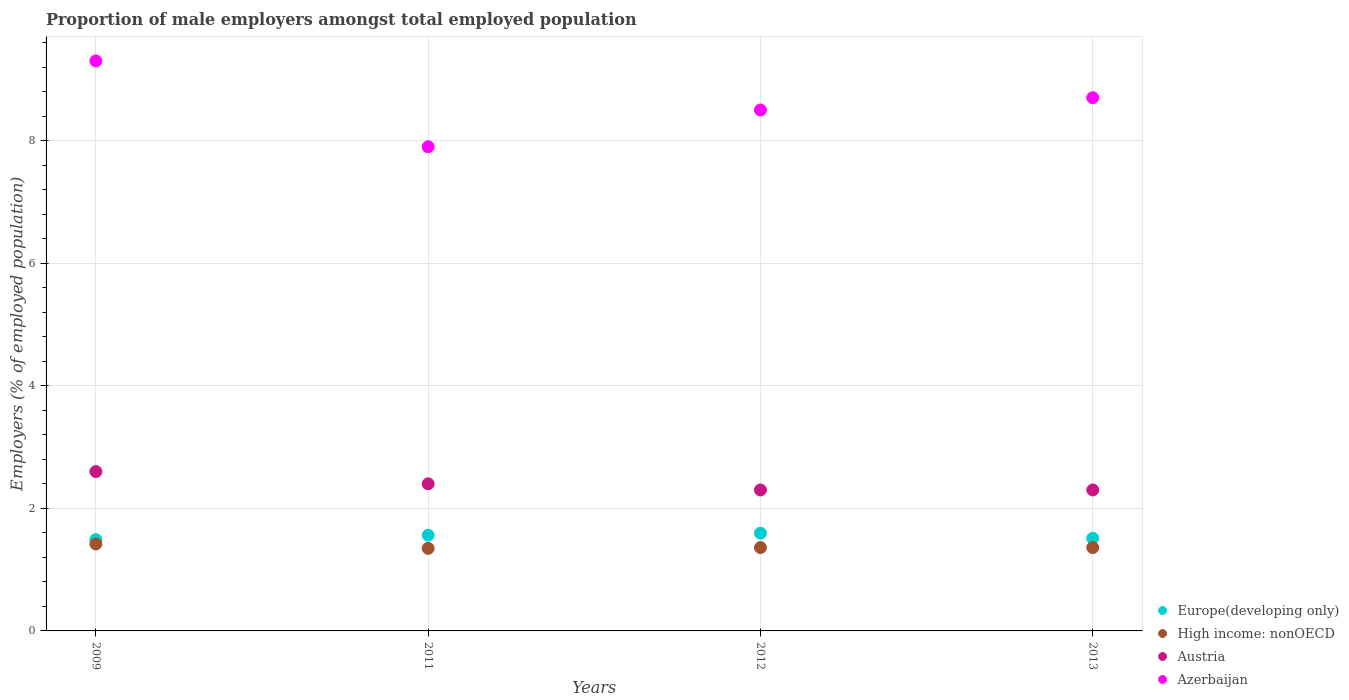What is the proportion of male employers in Austria in 2009?
Give a very brief answer. 2.6. Across all years, what is the maximum proportion of male employers in Azerbaijan?
Your response must be concise. 9.3. Across all years, what is the minimum proportion of male employers in Austria?
Keep it short and to the point. 2.3. In which year was the proportion of male employers in High income: nonOECD minimum?
Your answer should be very brief. 2011. What is the total proportion of male employers in Azerbaijan in the graph?
Offer a very short reply. 34.4. What is the difference between the proportion of male employers in High income: nonOECD in 2011 and that in 2013?
Keep it short and to the point. -0.01. What is the difference between the proportion of male employers in High income: nonOECD in 2013 and the proportion of male employers in Azerbaijan in 2012?
Keep it short and to the point. -7.14. What is the average proportion of male employers in Europe(developing only) per year?
Offer a very short reply. 1.54. In the year 2012, what is the difference between the proportion of male employers in Austria and proportion of male employers in High income: nonOECD?
Keep it short and to the point. 0.94. What is the ratio of the proportion of male employers in Europe(developing only) in 2011 to that in 2013?
Your answer should be compact. 1.03. What is the difference between the highest and the second highest proportion of male employers in Austria?
Make the answer very short. 0.2. What is the difference between the highest and the lowest proportion of male employers in Azerbaijan?
Make the answer very short. 1.4. Is the sum of the proportion of male employers in Europe(developing only) in 2009 and 2012 greater than the maximum proportion of male employers in High income: nonOECD across all years?
Make the answer very short. Yes. Is it the case that in every year, the sum of the proportion of male employers in High income: nonOECD and proportion of male employers in Austria  is greater than the proportion of male employers in Europe(developing only)?
Your answer should be compact. Yes. Does the proportion of male employers in High income: nonOECD monotonically increase over the years?
Give a very brief answer. No. How many years are there in the graph?
Your response must be concise. 4. What is the difference between two consecutive major ticks on the Y-axis?
Your answer should be very brief. 2. Are the values on the major ticks of Y-axis written in scientific E-notation?
Your response must be concise. No. Where does the legend appear in the graph?
Give a very brief answer. Bottom right. How are the legend labels stacked?
Ensure brevity in your answer.  Vertical. What is the title of the graph?
Provide a succinct answer. Proportion of male employers amongst total employed population. Does "Japan" appear as one of the legend labels in the graph?
Keep it short and to the point. No. What is the label or title of the Y-axis?
Keep it short and to the point. Employers (% of employed population). What is the Employers (% of employed population) of Europe(developing only) in 2009?
Make the answer very short. 1.49. What is the Employers (% of employed population) of High income: nonOECD in 2009?
Provide a succinct answer. 1.42. What is the Employers (% of employed population) in Austria in 2009?
Provide a succinct answer. 2.6. What is the Employers (% of employed population) in Azerbaijan in 2009?
Give a very brief answer. 9.3. What is the Employers (% of employed population) of Europe(developing only) in 2011?
Offer a very short reply. 1.56. What is the Employers (% of employed population) in High income: nonOECD in 2011?
Provide a succinct answer. 1.35. What is the Employers (% of employed population) of Austria in 2011?
Make the answer very short. 2.4. What is the Employers (% of employed population) in Azerbaijan in 2011?
Your answer should be compact. 7.9. What is the Employers (% of employed population) in Europe(developing only) in 2012?
Your response must be concise. 1.59. What is the Employers (% of employed population) of High income: nonOECD in 2012?
Your answer should be very brief. 1.36. What is the Employers (% of employed population) in Austria in 2012?
Provide a succinct answer. 2.3. What is the Employers (% of employed population) of Azerbaijan in 2012?
Offer a very short reply. 8.5. What is the Employers (% of employed population) in Europe(developing only) in 2013?
Give a very brief answer. 1.51. What is the Employers (% of employed population) of High income: nonOECD in 2013?
Keep it short and to the point. 1.36. What is the Employers (% of employed population) in Austria in 2013?
Offer a very short reply. 2.3. What is the Employers (% of employed population) of Azerbaijan in 2013?
Make the answer very short. 8.7. Across all years, what is the maximum Employers (% of employed population) of Europe(developing only)?
Your answer should be very brief. 1.59. Across all years, what is the maximum Employers (% of employed population) of High income: nonOECD?
Make the answer very short. 1.42. Across all years, what is the maximum Employers (% of employed population) of Austria?
Your answer should be compact. 2.6. Across all years, what is the maximum Employers (% of employed population) of Azerbaijan?
Your answer should be very brief. 9.3. Across all years, what is the minimum Employers (% of employed population) in Europe(developing only)?
Your response must be concise. 1.49. Across all years, what is the minimum Employers (% of employed population) of High income: nonOECD?
Offer a very short reply. 1.35. Across all years, what is the minimum Employers (% of employed population) in Austria?
Make the answer very short. 2.3. Across all years, what is the minimum Employers (% of employed population) in Azerbaijan?
Make the answer very short. 7.9. What is the total Employers (% of employed population) of Europe(developing only) in the graph?
Provide a succinct answer. 6.16. What is the total Employers (% of employed population) in High income: nonOECD in the graph?
Ensure brevity in your answer.  5.49. What is the total Employers (% of employed population) of Azerbaijan in the graph?
Provide a short and direct response. 34.4. What is the difference between the Employers (% of employed population) of Europe(developing only) in 2009 and that in 2011?
Your answer should be compact. -0.07. What is the difference between the Employers (% of employed population) in High income: nonOECD in 2009 and that in 2011?
Give a very brief answer. 0.07. What is the difference between the Employers (% of employed population) of Europe(developing only) in 2009 and that in 2012?
Keep it short and to the point. -0.11. What is the difference between the Employers (% of employed population) in High income: nonOECD in 2009 and that in 2012?
Your response must be concise. 0.06. What is the difference between the Employers (% of employed population) in Austria in 2009 and that in 2012?
Your response must be concise. 0.3. What is the difference between the Employers (% of employed population) in Azerbaijan in 2009 and that in 2012?
Offer a very short reply. 0.8. What is the difference between the Employers (% of employed population) of Europe(developing only) in 2009 and that in 2013?
Keep it short and to the point. -0.02. What is the difference between the Employers (% of employed population) in High income: nonOECD in 2009 and that in 2013?
Ensure brevity in your answer.  0.06. What is the difference between the Employers (% of employed population) of Austria in 2009 and that in 2013?
Give a very brief answer. 0.3. What is the difference between the Employers (% of employed population) in Azerbaijan in 2009 and that in 2013?
Provide a succinct answer. 0.6. What is the difference between the Employers (% of employed population) of Europe(developing only) in 2011 and that in 2012?
Offer a very short reply. -0.03. What is the difference between the Employers (% of employed population) in High income: nonOECD in 2011 and that in 2012?
Offer a very short reply. -0.01. What is the difference between the Employers (% of employed population) of Austria in 2011 and that in 2012?
Give a very brief answer. 0.1. What is the difference between the Employers (% of employed population) of Europe(developing only) in 2011 and that in 2013?
Your response must be concise. 0.05. What is the difference between the Employers (% of employed population) in High income: nonOECD in 2011 and that in 2013?
Your answer should be compact. -0.01. What is the difference between the Employers (% of employed population) in Azerbaijan in 2011 and that in 2013?
Ensure brevity in your answer.  -0.8. What is the difference between the Employers (% of employed population) in Europe(developing only) in 2012 and that in 2013?
Make the answer very short. 0.08. What is the difference between the Employers (% of employed population) of Austria in 2012 and that in 2013?
Your answer should be very brief. 0. What is the difference between the Employers (% of employed population) of Azerbaijan in 2012 and that in 2013?
Your response must be concise. -0.2. What is the difference between the Employers (% of employed population) of Europe(developing only) in 2009 and the Employers (% of employed population) of High income: nonOECD in 2011?
Your answer should be very brief. 0.14. What is the difference between the Employers (% of employed population) in Europe(developing only) in 2009 and the Employers (% of employed population) in Austria in 2011?
Your answer should be compact. -0.91. What is the difference between the Employers (% of employed population) of Europe(developing only) in 2009 and the Employers (% of employed population) of Azerbaijan in 2011?
Give a very brief answer. -6.41. What is the difference between the Employers (% of employed population) of High income: nonOECD in 2009 and the Employers (% of employed population) of Austria in 2011?
Give a very brief answer. -0.98. What is the difference between the Employers (% of employed population) of High income: nonOECD in 2009 and the Employers (% of employed population) of Azerbaijan in 2011?
Provide a short and direct response. -6.48. What is the difference between the Employers (% of employed population) in Austria in 2009 and the Employers (% of employed population) in Azerbaijan in 2011?
Provide a succinct answer. -5.3. What is the difference between the Employers (% of employed population) of Europe(developing only) in 2009 and the Employers (% of employed population) of High income: nonOECD in 2012?
Provide a succinct answer. 0.13. What is the difference between the Employers (% of employed population) of Europe(developing only) in 2009 and the Employers (% of employed population) of Austria in 2012?
Your answer should be very brief. -0.81. What is the difference between the Employers (% of employed population) in Europe(developing only) in 2009 and the Employers (% of employed population) in Azerbaijan in 2012?
Offer a very short reply. -7.01. What is the difference between the Employers (% of employed population) in High income: nonOECD in 2009 and the Employers (% of employed population) in Austria in 2012?
Your response must be concise. -0.88. What is the difference between the Employers (% of employed population) in High income: nonOECD in 2009 and the Employers (% of employed population) in Azerbaijan in 2012?
Offer a terse response. -7.08. What is the difference between the Employers (% of employed population) of Austria in 2009 and the Employers (% of employed population) of Azerbaijan in 2012?
Provide a short and direct response. -5.9. What is the difference between the Employers (% of employed population) of Europe(developing only) in 2009 and the Employers (% of employed population) of High income: nonOECD in 2013?
Ensure brevity in your answer.  0.13. What is the difference between the Employers (% of employed population) in Europe(developing only) in 2009 and the Employers (% of employed population) in Austria in 2013?
Your response must be concise. -0.81. What is the difference between the Employers (% of employed population) of Europe(developing only) in 2009 and the Employers (% of employed population) of Azerbaijan in 2013?
Offer a very short reply. -7.21. What is the difference between the Employers (% of employed population) in High income: nonOECD in 2009 and the Employers (% of employed population) in Austria in 2013?
Provide a succinct answer. -0.88. What is the difference between the Employers (% of employed population) of High income: nonOECD in 2009 and the Employers (% of employed population) of Azerbaijan in 2013?
Keep it short and to the point. -7.28. What is the difference between the Employers (% of employed population) of Europe(developing only) in 2011 and the Employers (% of employed population) of High income: nonOECD in 2012?
Your answer should be compact. 0.2. What is the difference between the Employers (% of employed population) of Europe(developing only) in 2011 and the Employers (% of employed population) of Austria in 2012?
Give a very brief answer. -0.74. What is the difference between the Employers (% of employed population) of Europe(developing only) in 2011 and the Employers (% of employed population) of Azerbaijan in 2012?
Your response must be concise. -6.94. What is the difference between the Employers (% of employed population) of High income: nonOECD in 2011 and the Employers (% of employed population) of Austria in 2012?
Give a very brief answer. -0.95. What is the difference between the Employers (% of employed population) of High income: nonOECD in 2011 and the Employers (% of employed population) of Azerbaijan in 2012?
Provide a short and direct response. -7.15. What is the difference between the Employers (% of employed population) in Austria in 2011 and the Employers (% of employed population) in Azerbaijan in 2012?
Provide a short and direct response. -6.1. What is the difference between the Employers (% of employed population) in Europe(developing only) in 2011 and the Employers (% of employed population) in High income: nonOECD in 2013?
Your answer should be compact. 0.2. What is the difference between the Employers (% of employed population) in Europe(developing only) in 2011 and the Employers (% of employed population) in Austria in 2013?
Your answer should be compact. -0.74. What is the difference between the Employers (% of employed population) of Europe(developing only) in 2011 and the Employers (% of employed population) of Azerbaijan in 2013?
Make the answer very short. -7.14. What is the difference between the Employers (% of employed population) of High income: nonOECD in 2011 and the Employers (% of employed population) of Austria in 2013?
Ensure brevity in your answer.  -0.95. What is the difference between the Employers (% of employed population) in High income: nonOECD in 2011 and the Employers (% of employed population) in Azerbaijan in 2013?
Provide a succinct answer. -7.35. What is the difference between the Employers (% of employed population) of Europe(developing only) in 2012 and the Employers (% of employed population) of High income: nonOECD in 2013?
Provide a succinct answer. 0.24. What is the difference between the Employers (% of employed population) in Europe(developing only) in 2012 and the Employers (% of employed population) in Austria in 2013?
Offer a very short reply. -0.71. What is the difference between the Employers (% of employed population) in Europe(developing only) in 2012 and the Employers (% of employed population) in Azerbaijan in 2013?
Offer a very short reply. -7.11. What is the difference between the Employers (% of employed population) in High income: nonOECD in 2012 and the Employers (% of employed population) in Austria in 2013?
Offer a very short reply. -0.94. What is the difference between the Employers (% of employed population) of High income: nonOECD in 2012 and the Employers (% of employed population) of Azerbaijan in 2013?
Keep it short and to the point. -7.34. What is the average Employers (% of employed population) of Europe(developing only) per year?
Your response must be concise. 1.54. What is the average Employers (% of employed population) in High income: nonOECD per year?
Give a very brief answer. 1.37. What is the average Employers (% of employed population) in Azerbaijan per year?
Offer a very short reply. 8.6. In the year 2009, what is the difference between the Employers (% of employed population) of Europe(developing only) and Employers (% of employed population) of High income: nonOECD?
Give a very brief answer. 0.07. In the year 2009, what is the difference between the Employers (% of employed population) in Europe(developing only) and Employers (% of employed population) in Austria?
Your answer should be very brief. -1.11. In the year 2009, what is the difference between the Employers (% of employed population) in Europe(developing only) and Employers (% of employed population) in Azerbaijan?
Keep it short and to the point. -7.81. In the year 2009, what is the difference between the Employers (% of employed population) in High income: nonOECD and Employers (% of employed population) in Austria?
Your answer should be very brief. -1.18. In the year 2009, what is the difference between the Employers (% of employed population) of High income: nonOECD and Employers (% of employed population) of Azerbaijan?
Offer a terse response. -7.88. In the year 2011, what is the difference between the Employers (% of employed population) in Europe(developing only) and Employers (% of employed population) in High income: nonOECD?
Keep it short and to the point. 0.22. In the year 2011, what is the difference between the Employers (% of employed population) in Europe(developing only) and Employers (% of employed population) in Austria?
Provide a succinct answer. -0.84. In the year 2011, what is the difference between the Employers (% of employed population) of Europe(developing only) and Employers (% of employed population) of Azerbaijan?
Your response must be concise. -6.34. In the year 2011, what is the difference between the Employers (% of employed population) in High income: nonOECD and Employers (% of employed population) in Austria?
Offer a terse response. -1.05. In the year 2011, what is the difference between the Employers (% of employed population) of High income: nonOECD and Employers (% of employed population) of Azerbaijan?
Make the answer very short. -6.55. In the year 2012, what is the difference between the Employers (% of employed population) in Europe(developing only) and Employers (% of employed population) in High income: nonOECD?
Your response must be concise. 0.23. In the year 2012, what is the difference between the Employers (% of employed population) in Europe(developing only) and Employers (% of employed population) in Austria?
Ensure brevity in your answer.  -0.71. In the year 2012, what is the difference between the Employers (% of employed population) in Europe(developing only) and Employers (% of employed population) in Azerbaijan?
Give a very brief answer. -6.91. In the year 2012, what is the difference between the Employers (% of employed population) in High income: nonOECD and Employers (% of employed population) in Austria?
Make the answer very short. -0.94. In the year 2012, what is the difference between the Employers (% of employed population) in High income: nonOECD and Employers (% of employed population) in Azerbaijan?
Offer a very short reply. -7.14. In the year 2013, what is the difference between the Employers (% of employed population) of Europe(developing only) and Employers (% of employed population) of High income: nonOECD?
Ensure brevity in your answer.  0.15. In the year 2013, what is the difference between the Employers (% of employed population) of Europe(developing only) and Employers (% of employed population) of Austria?
Your answer should be very brief. -0.79. In the year 2013, what is the difference between the Employers (% of employed population) in Europe(developing only) and Employers (% of employed population) in Azerbaijan?
Make the answer very short. -7.19. In the year 2013, what is the difference between the Employers (% of employed population) in High income: nonOECD and Employers (% of employed population) in Austria?
Your response must be concise. -0.94. In the year 2013, what is the difference between the Employers (% of employed population) of High income: nonOECD and Employers (% of employed population) of Azerbaijan?
Offer a terse response. -7.34. In the year 2013, what is the difference between the Employers (% of employed population) of Austria and Employers (% of employed population) of Azerbaijan?
Give a very brief answer. -6.4. What is the ratio of the Employers (% of employed population) in Europe(developing only) in 2009 to that in 2011?
Provide a succinct answer. 0.95. What is the ratio of the Employers (% of employed population) of High income: nonOECD in 2009 to that in 2011?
Keep it short and to the point. 1.05. What is the ratio of the Employers (% of employed population) in Austria in 2009 to that in 2011?
Offer a terse response. 1.08. What is the ratio of the Employers (% of employed population) of Azerbaijan in 2009 to that in 2011?
Your response must be concise. 1.18. What is the ratio of the Employers (% of employed population) in Europe(developing only) in 2009 to that in 2012?
Offer a very short reply. 0.93. What is the ratio of the Employers (% of employed population) of High income: nonOECD in 2009 to that in 2012?
Your answer should be very brief. 1.04. What is the ratio of the Employers (% of employed population) in Austria in 2009 to that in 2012?
Keep it short and to the point. 1.13. What is the ratio of the Employers (% of employed population) of Azerbaijan in 2009 to that in 2012?
Your answer should be compact. 1.09. What is the ratio of the Employers (% of employed population) of Europe(developing only) in 2009 to that in 2013?
Make the answer very short. 0.99. What is the ratio of the Employers (% of employed population) of High income: nonOECD in 2009 to that in 2013?
Your answer should be very brief. 1.04. What is the ratio of the Employers (% of employed population) in Austria in 2009 to that in 2013?
Provide a succinct answer. 1.13. What is the ratio of the Employers (% of employed population) in Azerbaijan in 2009 to that in 2013?
Your answer should be very brief. 1.07. What is the ratio of the Employers (% of employed population) of Europe(developing only) in 2011 to that in 2012?
Your response must be concise. 0.98. What is the ratio of the Employers (% of employed population) of Austria in 2011 to that in 2012?
Your answer should be very brief. 1.04. What is the ratio of the Employers (% of employed population) in Azerbaijan in 2011 to that in 2012?
Provide a short and direct response. 0.93. What is the ratio of the Employers (% of employed population) in Europe(developing only) in 2011 to that in 2013?
Ensure brevity in your answer.  1.03. What is the ratio of the Employers (% of employed population) of High income: nonOECD in 2011 to that in 2013?
Provide a succinct answer. 0.99. What is the ratio of the Employers (% of employed population) in Austria in 2011 to that in 2013?
Provide a short and direct response. 1.04. What is the ratio of the Employers (% of employed population) of Azerbaijan in 2011 to that in 2013?
Offer a terse response. 0.91. What is the ratio of the Employers (% of employed population) of Europe(developing only) in 2012 to that in 2013?
Provide a succinct answer. 1.06. What is the ratio of the Employers (% of employed population) of Austria in 2012 to that in 2013?
Your answer should be very brief. 1. What is the difference between the highest and the second highest Employers (% of employed population) of Europe(developing only)?
Offer a very short reply. 0.03. What is the difference between the highest and the second highest Employers (% of employed population) in High income: nonOECD?
Ensure brevity in your answer.  0.06. What is the difference between the highest and the second highest Employers (% of employed population) of Azerbaijan?
Offer a terse response. 0.6. What is the difference between the highest and the lowest Employers (% of employed population) in Europe(developing only)?
Your answer should be compact. 0.11. What is the difference between the highest and the lowest Employers (% of employed population) of High income: nonOECD?
Make the answer very short. 0.07. What is the difference between the highest and the lowest Employers (% of employed population) of Austria?
Provide a short and direct response. 0.3. What is the difference between the highest and the lowest Employers (% of employed population) of Azerbaijan?
Offer a terse response. 1.4. 